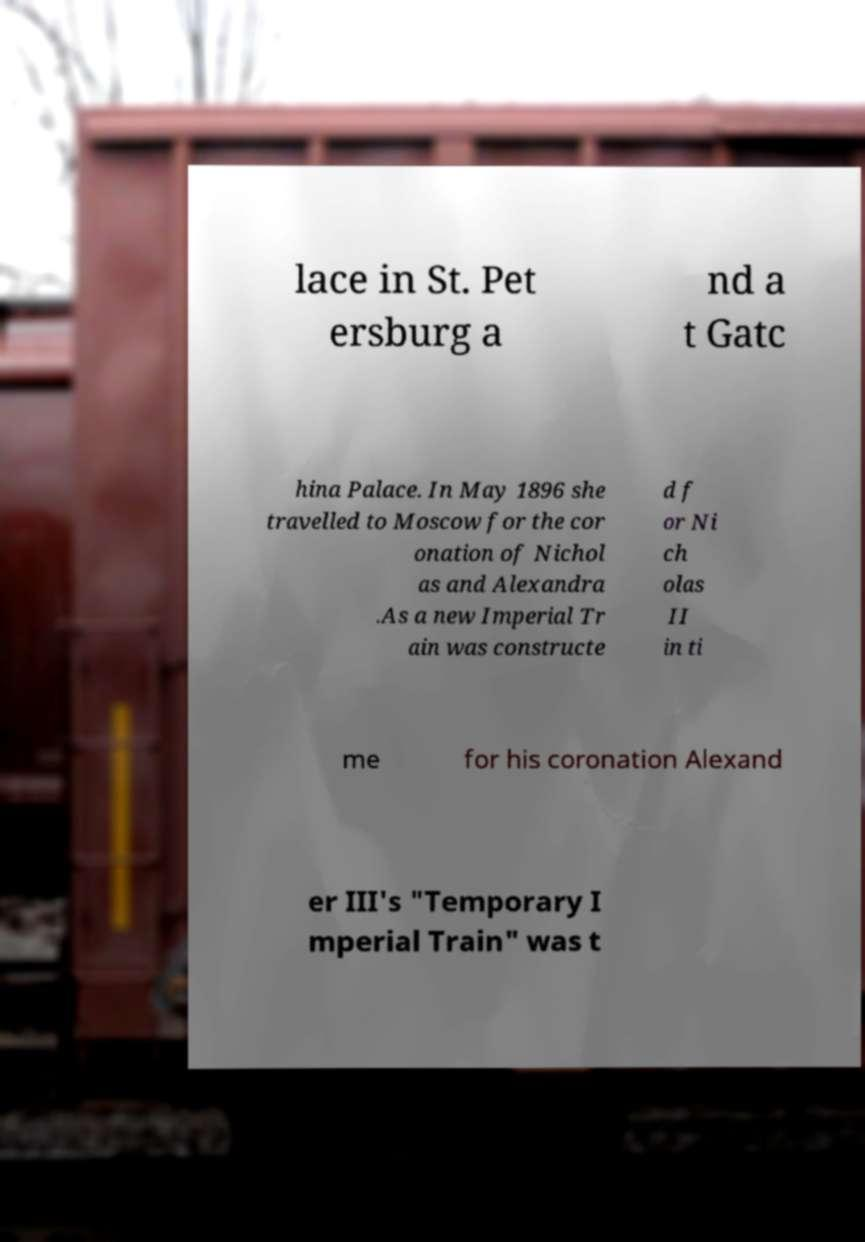For documentation purposes, I need the text within this image transcribed. Could you provide that? lace in St. Pet ersburg a nd a t Gatc hina Palace. In May 1896 she travelled to Moscow for the cor onation of Nichol as and Alexandra .As a new Imperial Tr ain was constructe d f or Ni ch olas II in ti me for his coronation Alexand er III's "Temporary I mperial Train" was t 